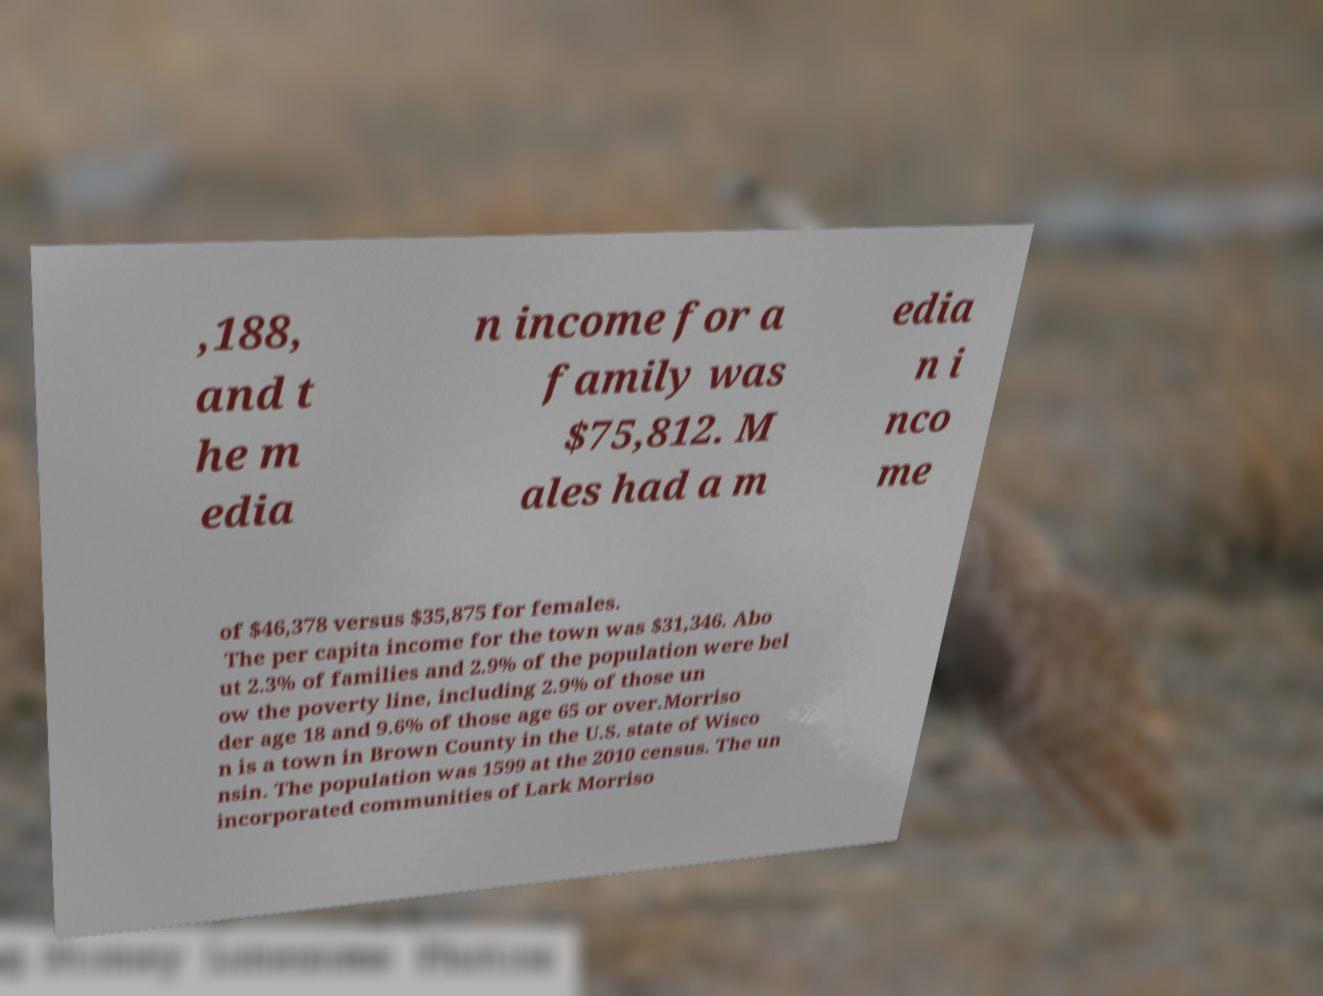Could you assist in decoding the text presented in this image and type it out clearly? ,188, and t he m edia n income for a family was $75,812. M ales had a m edia n i nco me of $46,378 versus $35,875 for females. The per capita income for the town was $31,346. Abo ut 2.3% of families and 2.9% of the population were bel ow the poverty line, including 2.9% of those un der age 18 and 9.6% of those age 65 or over.Morriso n is a town in Brown County in the U.S. state of Wisco nsin. The population was 1599 at the 2010 census. The un incorporated communities of Lark Morriso 